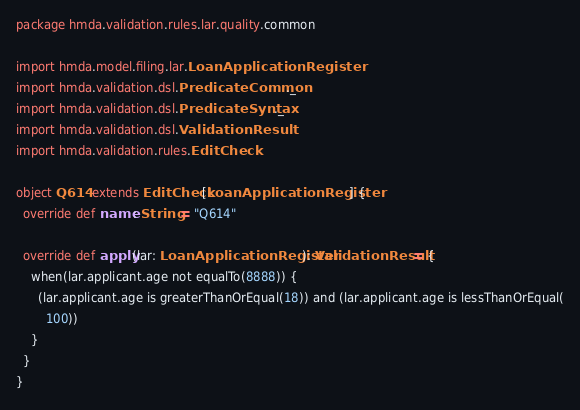Convert code to text. <code><loc_0><loc_0><loc_500><loc_500><_Scala_>package hmda.validation.rules.lar.quality.common

import hmda.model.filing.lar.LoanApplicationRegister
import hmda.validation.dsl.PredicateCommon._
import hmda.validation.dsl.PredicateSyntax._
import hmda.validation.dsl.ValidationResult
import hmda.validation.rules.EditCheck

object Q614 extends EditCheck[LoanApplicationRegister] {
  override def name: String = "Q614"

  override def apply(lar: LoanApplicationRegister): ValidationResult = {
    when(lar.applicant.age not equalTo(8888)) {
      (lar.applicant.age is greaterThanOrEqual(18)) and (lar.applicant.age is lessThanOrEqual(
        100))
    }
  }
}
</code> 